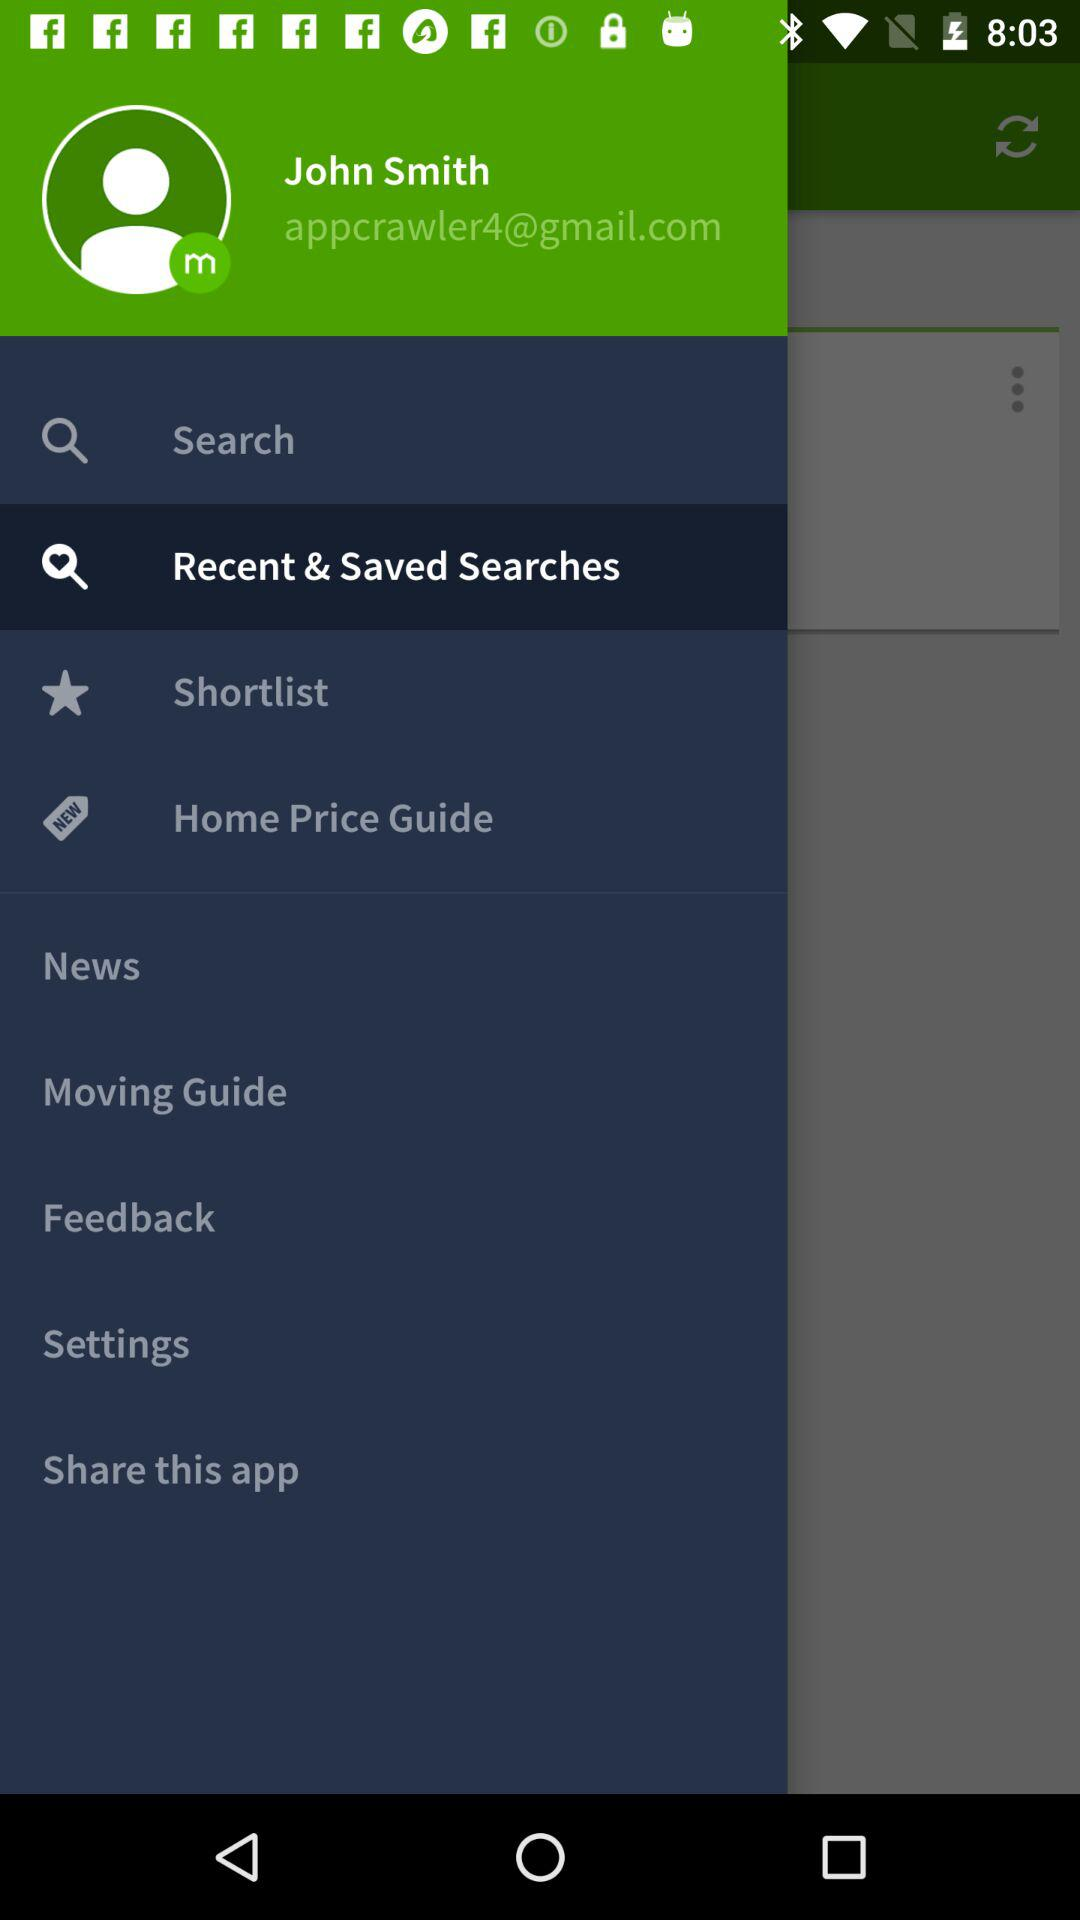What is the user name? The user name is John Smith. 